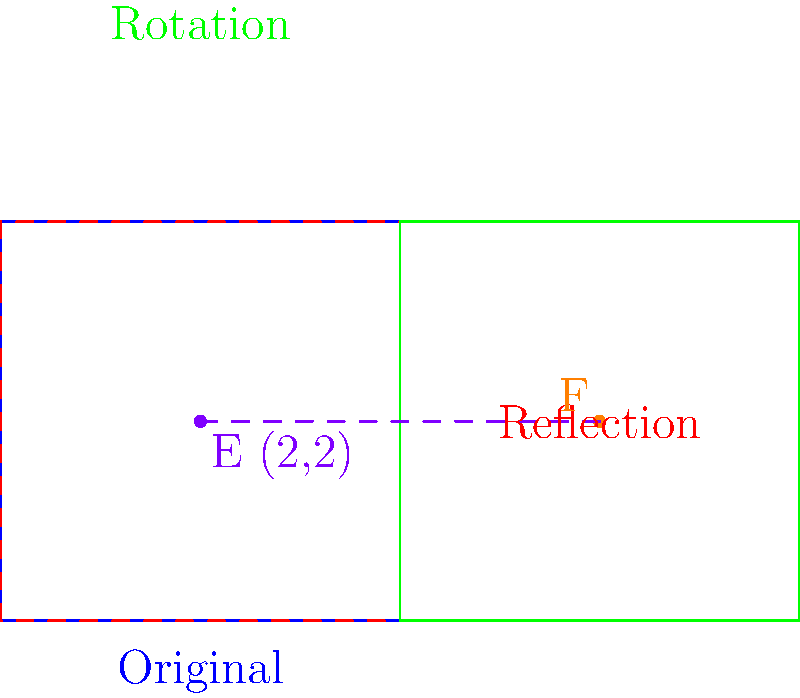A medical chart representing the relationship between physical and mental health factors is transformed to highlight different aspects. The original chart is represented by the blue rectangle. It undergoes a reflection about the diagonal from (0,0) to (4,4), followed by a 90° clockwise rotation around the point (4,4). Point E at (2,2) represents a patient's initial health status.

1. What are the coordinates of point F, which represents the patient's health status after the transformations?
2. How does this transformation of the chart help in visualizing the interplay between physical and mental health factors? 1. To find the coordinates of point F:

   Step 1: Reflect point E(2,2) about the diagonal from (0,0) to (4,4).
   - The reflection of (x,y) about this diagonal is (y,x).
   - So, after reflection, E becomes (2,2).

   Step 2: Rotate the reflected point 90° clockwise around (4,4).
   - To rotate (x,y) 90° clockwise around (a,b), use: (a+b-y, b-a+x)
   - Here, (a,b) = (4,4) and (x,y) = (2,2)
   - F = (4+4-2, 4-4+2) = (6,2)

2. This transformation helps visualize the interplay between physical and mental health factors by:
   - Reflection: Swaps the axes, potentially highlighting how physical and mental health factors can influence each other.
   - Rotation: Provides a new perspective on the data, potentially revealing patterns or relationships that weren't apparent in the original orientation.
   - The combination of these transformations encourages a holistic view of the patient's health, emphasizing the interconnectedness of physical and mental well-being.
Answer: 1. F(6,2)
2. It reveals hidden patterns and emphasizes the interconnectedness of physical and mental health factors. 